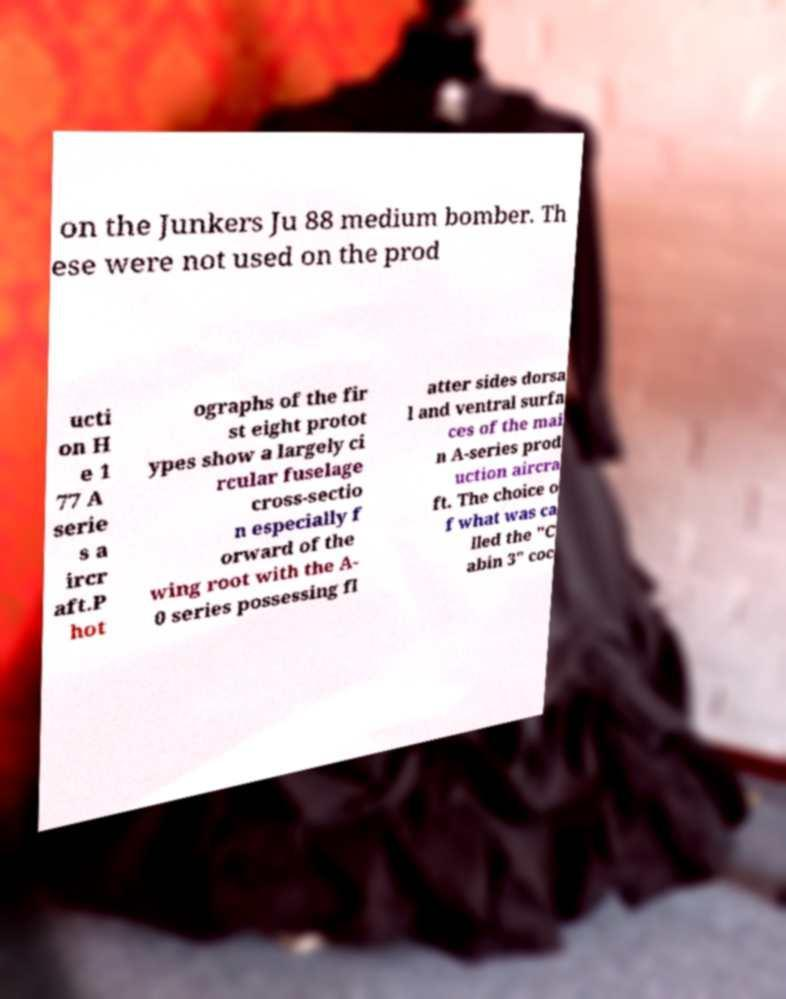Can you read and provide the text displayed in the image?This photo seems to have some interesting text. Can you extract and type it out for me? on the Junkers Ju 88 medium bomber. Th ese were not used on the prod ucti on H e 1 77 A serie s a ircr aft.P hot ographs of the fir st eight protot ypes show a largely ci rcular fuselage cross-sectio n especially f orward of the wing root with the A- 0 series possessing fl atter sides dorsa l and ventral surfa ces of the mai n A-series prod uction aircra ft. The choice o f what was ca lled the "C abin 3" coc 